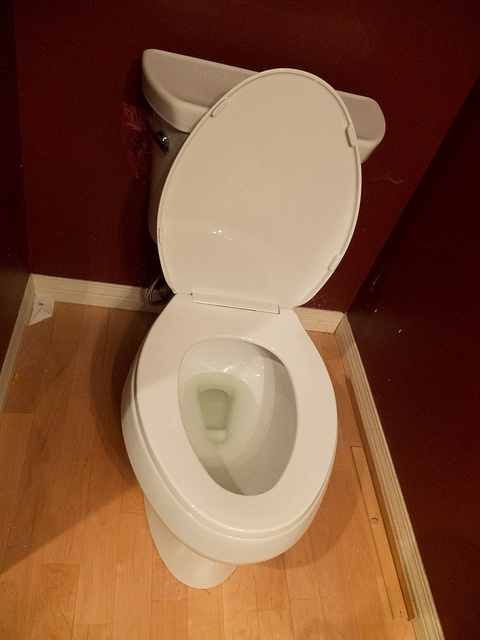Describe the objects in this image and their specific colors. I can see a toilet in black, tan, and gray tones in this image. 